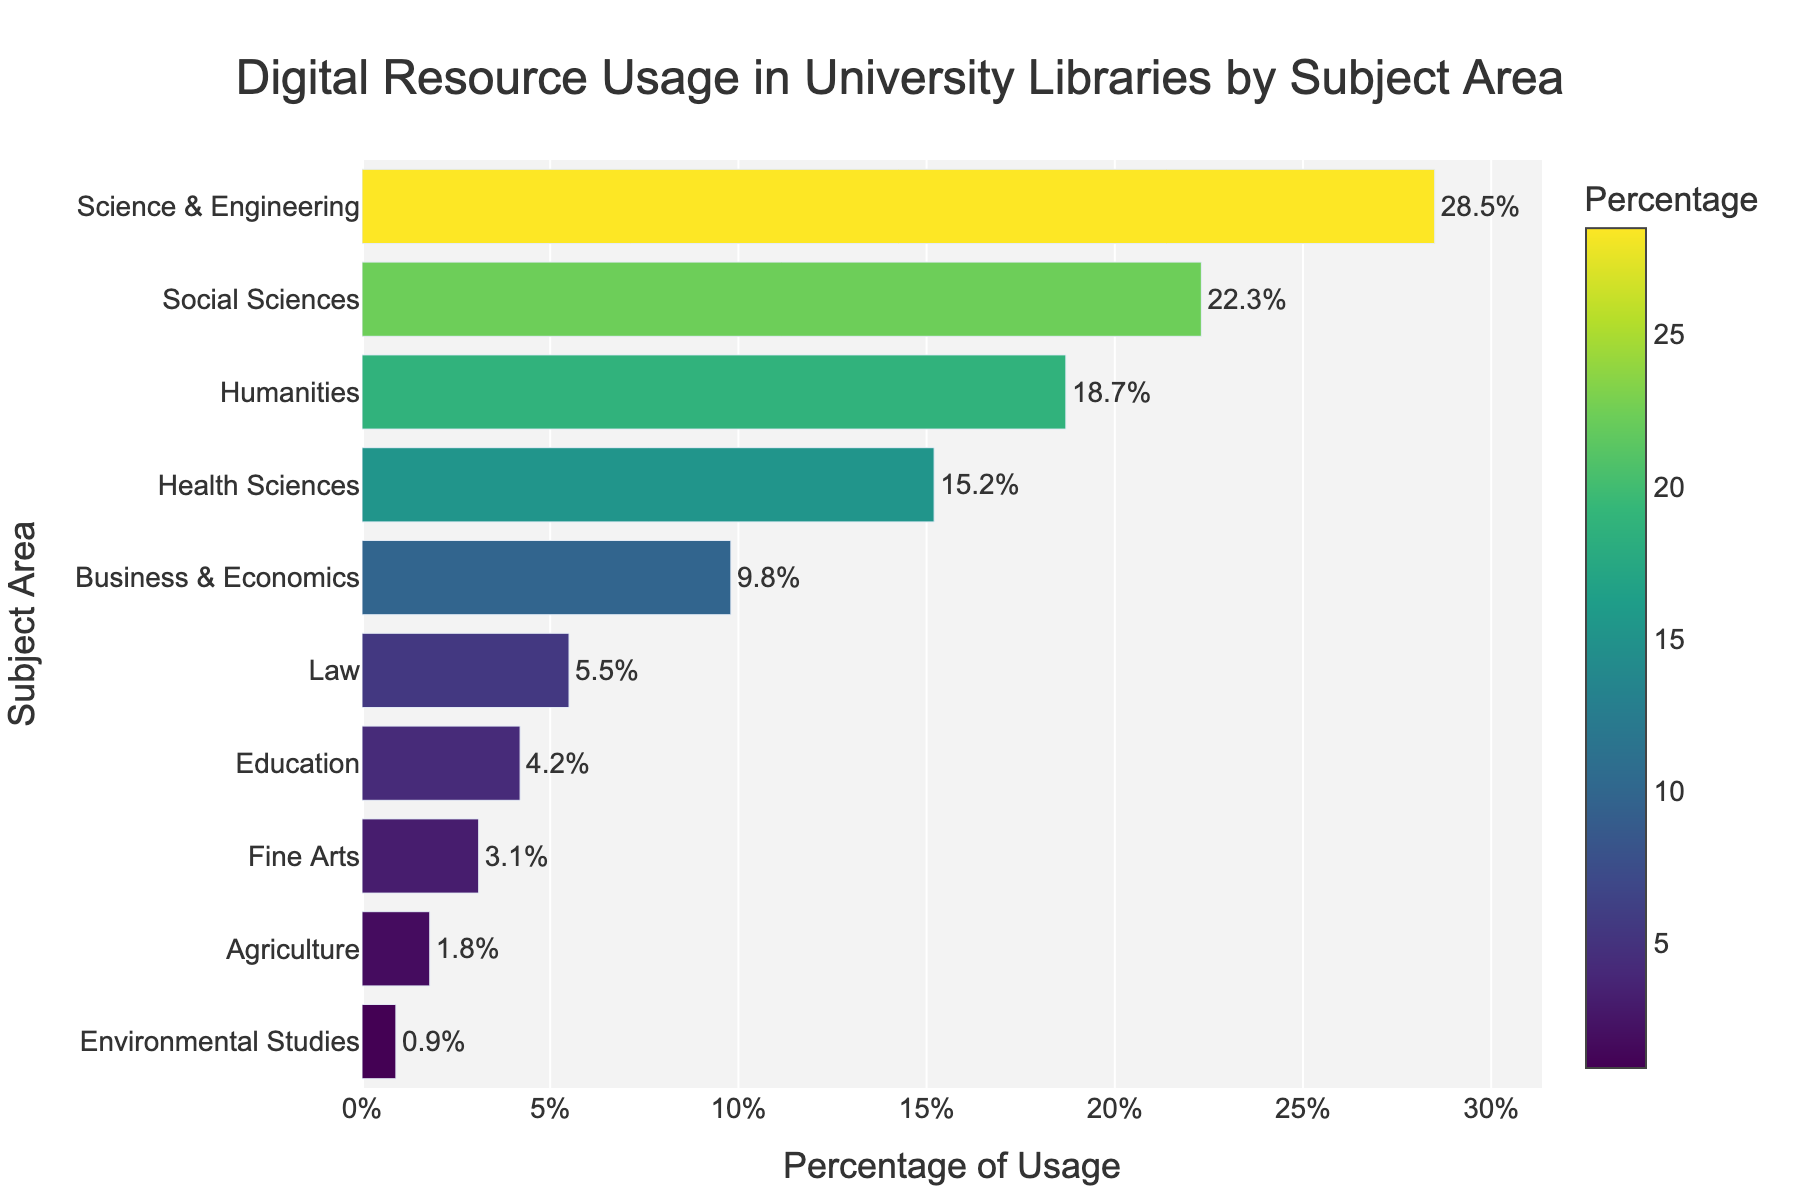Which subject area has the highest digital resource usage? The bar representing Science & Engineering has the longest length, indicating it has the highest percentage of digital resource usage.
Answer: Science & Engineering Which two subject areas have the lowest digital resource usage? The bars for Environmental Studies and Agriculture are the shortest, so these two subject areas have the lowest percentages of digital resource usage.
Answer: Environmental Studies and Agriculture What is the combined percentage of digital resource usage for Law, Education, and Fine Arts? The percentages for Law, Education, and Fine Arts are 5.5%, 4.2%, and 3.1% respectively. Adding these percentages gives: 5.5% + 4.2% + 3.1% = 12.8%.
Answer: 12.8% How much more digital resource usage does Health Sciences have compared to Business & Economics? The percentage for Health Sciences is 15.2% and for Business & Economics is 9.8%. The difference is 15.2% - 9.8% = 5.4%.
Answer: 5.4% Rank the top three subject areas by digital resource usage. The top three subject areas by percentage are Science & Engineering (28.5%), Social Sciences (22.3%), and Humanities (18.7%).
Answer: Science & Engineering, Social Sciences, Humanities Which subject area has a percentage closest to 20%? Social Sciences has a percentage of 22.3%, which is closest to 20% compared to others.
Answer: Social Sciences What is the average digital resource usage percentage for the top five subject areas? The percentages for the top five subject areas are Science & Engineering (28.5%), Social Sciences (22.3%), Humanities (18.7%), Health Sciences (15.2%), and Business & Economics (9.8%). Their average is calculated as (28.5 + 22.3 + 18.7 + 15.2 + 9.8) / 5 = 18.9%.
Answer: 18.9% Which subject area is represented with a percentage of less than 5% but more than 3%? Education has a percentage of 4.2%, which falls within the range of less than 5% but more than 3%.
Answer: Education By how much does the usage percentage of Social Sciences exceed that of Humanities? The percentage for Social Sciences is 22.3% and for Humanities is 18.7%. The difference is 22.3% - 18.7% = 3.6%.
Answer: 3.6% 